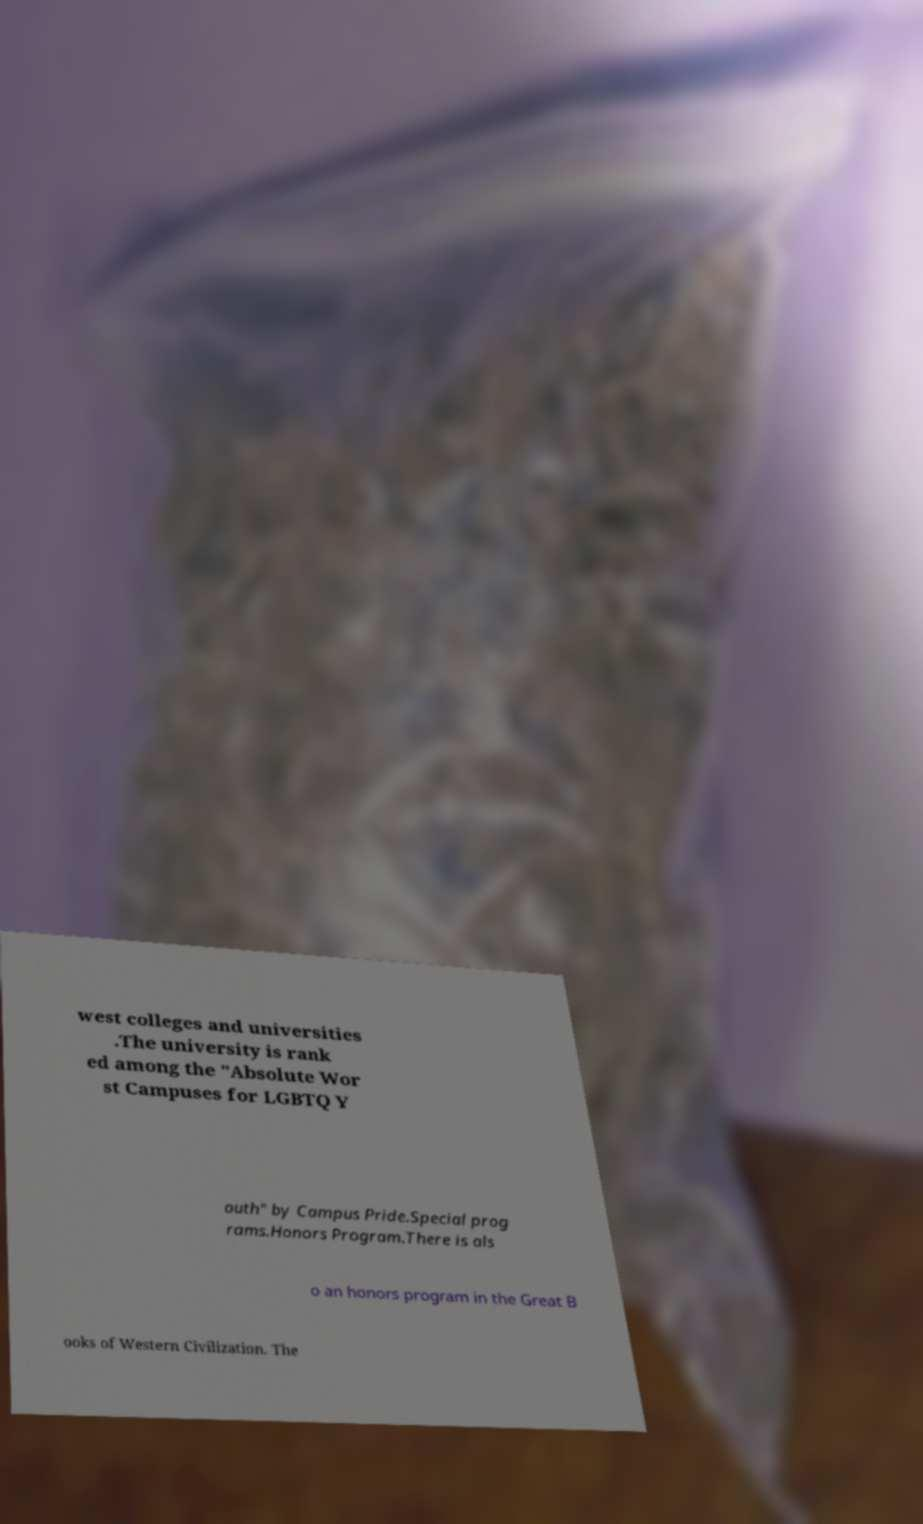For documentation purposes, I need the text within this image transcribed. Could you provide that? west colleges and universities .The university is rank ed among the "Absolute Wor st Campuses for LGBTQ Y outh" by Campus Pride.Special prog rams.Honors Program.There is als o an honors program in the Great B ooks of Western Civilization. The 